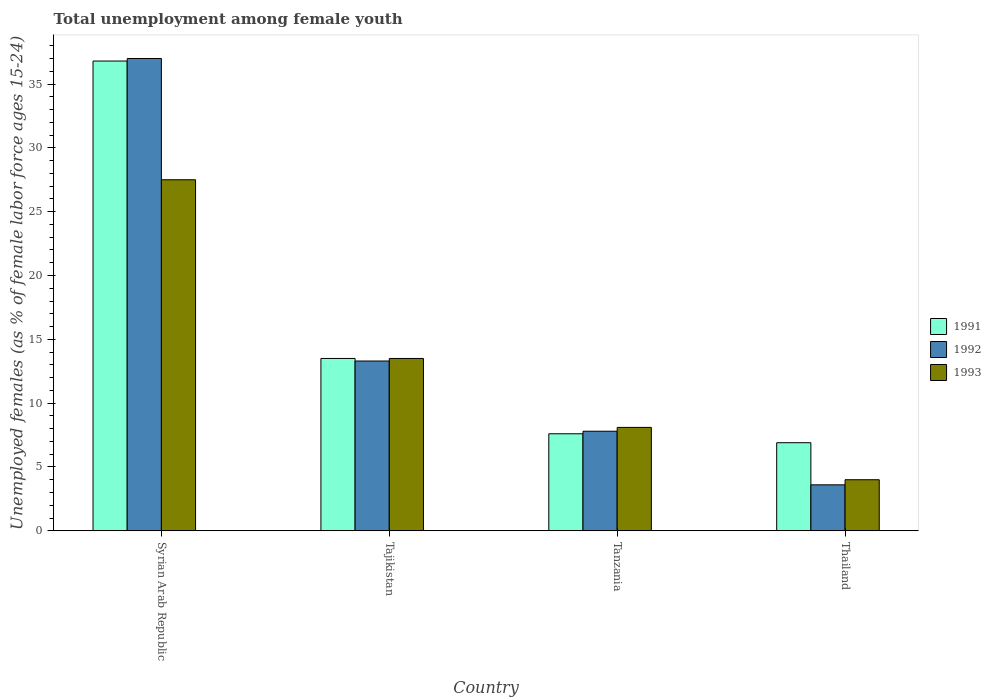How many different coloured bars are there?
Your answer should be compact. 3. How many groups of bars are there?
Your answer should be compact. 4. Are the number of bars per tick equal to the number of legend labels?
Provide a short and direct response. Yes. How many bars are there on the 1st tick from the left?
Your answer should be very brief. 3. What is the label of the 1st group of bars from the left?
Your response must be concise. Syrian Arab Republic. What is the percentage of unemployed females in in 1991 in Syrian Arab Republic?
Your answer should be very brief. 36.8. Across all countries, what is the maximum percentage of unemployed females in in 1992?
Ensure brevity in your answer.  37. In which country was the percentage of unemployed females in in 1991 maximum?
Make the answer very short. Syrian Arab Republic. In which country was the percentage of unemployed females in in 1991 minimum?
Give a very brief answer. Thailand. What is the total percentage of unemployed females in in 1991 in the graph?
Offer a very short reply. 64.8. What is the difference between the percentage of unemployed females in in 1991 in Tanzania and that in Thailand?
Offer a very short reply. 0.7. What is the difference between the percentage of unemployed females in in 1993 in Syrian Arab Republic and the percentage of unemployed females in in 1991 in Tanzania?
Make the answer very short. 19.9. What is the average percentage of unemployed females in in 1991 per country?
Offer a terse response. 16.2. What is the ratio of the percentage of unemployed females in in 1992 in Syrian Arab Republic to that in Tanzania?
Ensure brevity in your answer.  4.74. Is the difference between the percentage of unemployed females in in 1992 in Syrian Arab Republic and Tanzania greater than the difference between the percentage of unemployed females in in 1993 in Syrian Arab Republic and Tanzania?
Provide a short and direct response. Yes. What is the difference between the highest and the second highest percentage of unemployed females in in 1992?
Offer a terse response. -23.7. What is the difference between the highest and the lowest percentage of unemployed females in in 1992?
Offer a very short reply. 33.4. What does the 2nd bar from the left in Syrian Arab Republic represents?
Your answer should be compact. 1992. What does the 1st bar from the right in Syrian Arab Republic represents?
Give a very brief answer. 1993. Is it the case that in every country, the sum of the percentage of unemployed females in in 1991 and percentage of unemployed females in in 1993 is greater than the percentage of unemployed females in in 1992?
Your answer should be very brief. Yes. How many countries are there in the graph?
Give a very brief answer. 4. What is the difference between two consecutive major ticks on the Y-axis?
Ensure brevity in your answer.  5. Are the values on the major ticks of Y-axis written in scientific E-notation?
Provide a short and direct response. No. Does the graph contain any zero values?
Provide a short and direct response. No. Where does the legend appear in the graph?
Make the answer very short. Center right. How many legend labels are there?
Offer a terse response. 3. What is the title of the graph?
Offer a very short reply. Total unemployment among female youth. What is the label or title of the Y-axis?
Ensure brevity in your answer.  Unemployed females (as % of female labor force ages 15-24). What is the Unemployed females (as % of female labor force ages 15-24) in 1991 in Syrian Arab Republic?
Provide a succinct answer. 36.8. What is the Unemployed females (as % of female labor force ages 15-24) of 1991 in Tajikistan?
Provide a succinct answer. 13.5. What is the Unemployed females (as % of female labor force ages 15-24) in 1992 in Tajikistan?
Your answer should be very brief. 13.3. What is the Unemployed females (as % of female labor force ages 15-24) of 1993 in Tajikistan?
Keep it short and to the point. 13.5. What is the Unemployed females (as % of female labor force ages 15-24) in 1991 in Tanzania?
Provide a succinct answer. 7.6. What is the Unemployed females (as % of female labor force ages 15-24) in 1992 in Tanzania?
Your answer should be very brief. 7.8. What is the Unemployed females (as % of female labor force ages 15-24) in 1993 in Tanzania?
Offer a terse response. 8.1. What is the Unemployed females (as % of female labor force ages 15-24) in 1991 in Thailand?
Your answer should be very brief. 6.9. What is the Unemployed females (as % of female labor force ages 15-24) of 1992 in Thailand?
Offer a very short reply. 3.6. Across all countries, what is the maximum Unemployed females (as % of female labor force ages 15-24) in 1991?
Your answer should be very brief. 36.8. Across all countries, what is the maximum Unemployed females (as % of female labor force ages 15-24) in 1992?
Offer a terse response. 37. Across all countries, what is the minimum Unemployed females (as % of female labor force ages 15-24) in 1991?
Your response must be concise. 6.9. Across all countries, what is the minimum Unemployed females (as % of female labor force ages 15-24) of 1992?
Keep it short and to the point. 3.6. What is the total Unemployed females (as % of female labor force ages 15-24) in 1991 in the graph?
Provide a short and direct response. 64.8. What is the total Unemployed females (as % of female labor force ages 15-24) of 1992 in the graph?
Offer a very short reply. 61.7. What is the total Unemployed females (as % of female labor force ages 15-24) of 1993 in the graph?
Your response must be concise. 53.1. What is the difference between the Unemployed females (as % of female labor force ages 15-24) in 1991 in Syrian Arab Republic and that in Tajikistan?
Your response must be concise. 23.3. What is the difference between the Unemployed females (as % of female labor force ages 15-24) in 1992 in Syrian Arab Republic and that in Tajikistan?
Offer a very short reply. 23.7. What is the difference between the Unemployed females (as % of female labor force ages 15-24) of 1991 in Syrian Arab Republic and that in Tanzania?
Provide a short and direct response. 29.2. What is the difference between the Unemployed females (as % of female labor force ages 15-24) in 1992 in Syrian Arab Republic and that in Tanzania?
Provide a succinct answer. 29.2. What is the difference between the Unemployed females (as % of female labor force ages 15-24) in 1991 in Syrian Arab Republic and that in Thailand?
Provide a short and direct response. 29.9. What is the difference between the Unemployed females (as % of female labor force ages 15-24) in 1992 in Syrian Arab Republic and that in Thailand?
Ensure brevity in your answer.  33.4. What is the difference between the Unemployed females (as % of female labor force ages 15-24) of 1993 in Syrian Arab Republic and that in Thailand?
Your response must be concise. 23.5. What is the difference between the Unemployed females (as % of female labor force ages 15-24) of 1991 in Tajikistan and that in Thailand?
Provide a succinct answer. 6.6. What is the difference between the Unemployed females (as % of female labor force ages 15-24) of 1993 in Tajikistan and that in Thailand?
Keep it short and to the point. 9.5. What is the difference between the Unemployed females (as % of female labor force ages 15-24) in 1991 in Syrian Arab Republic and the Unemployed females (as % of female labor force ages 15-24) in 1993 in Tajikistan?
Give a very brief answer. 23.3. What is the difference between the Unemployed females (as % of female labor force ages 15-24) of 1991 in Syrian Arab Republic and the Unemployed females (as % of female labor force ages 15-24) of 1993 in Tanzania?
Make the answer very short. 28.7. What is the difference between the Unemployed females (as % of female labor force ages 15-24) in 1992 in Syrian Arab Republic and the Unemployed females (as % of female labor force ages 15-24) in 1993 in Tanzania?
Keep it short and to the point. 28.9. What is the difference between the Unemployed females (as % of female labor force ages 15-24) of 1991 in Syrian Arab Republic and the Unemployed females (as % of female labor force ages 15-24) of 1992 in Thailand?
Your answer should be compact. 33.2. What is the difference between the Unemployed females (as % of female labor force ages 15-24) of 1991 in Syrian Arab Republic and the Unemployed females (as % of female labor force ages 15-24) of 1993 in Thailand?
Provide a short and direct response. 32.8. What is the difference between the Unemployed females (as % of female labor force ages 15-24) of 1992 in Syrian Arab Republic and the Unemployed females (as % of female labor force ages 15-24) of 1993 in Thailand?
Offer a very short reply. 33. What is the difference between the Unemployed females (as % of female labor force ages 15-24) of 1991 in Tajikistan and the Unemployed females (as % of female labor force ages 15-24) of 1992 in Thailand?
Your answer should be compact. 9.9. What is the difference between the Unemployed females (as % of female labor force ages 15-24) of 1991 in Tajikistan and the Unemployed females (as % of female labor force ages 15-24) of 1993 in Thailand?
Offer a terse response. 9.5. What is the difference between the Unemployed females (as % of female labor force ages 15-24) of 1992 in Tajikistan and the Unemployed females (as % of female labor force ages 15-24) of 1993 in Thailand?
Your answer should be compact. 9.3. What is the difference between the Unemployed females (as % of female labor force ages 15-24) of 1991 in Tanzania and the Unemployed females (as % of female labor force ages 15-24) of 1992 in Thailand?
Your answer should be very brief. 4. What is the average Unemployed females (as % of female labor force ages 15-24) in 1991 per country?
Offer a very short reply. 16.2. What is the average Unemployed females (as % of female labor force ages 15-24) of 1992 per country?
Give a very brief answer. 15.43. What is the average Unemployed females (as % of female labor force ages 15-24) of 1993 per country?
Offer a terse response. 13.28. What is the difference between the Unemployed females (as % of female labor force ages 15-24) in 1991 and Unemployed females (as % of female labor force ages 15-24) in 1993 in Syrian Arab Republic?
Offer a terse response. 9.3. What is the difference between the Unemployed females (as % of female labor force ages 15-24) in 1992 and Unemployed females (as % of female labor force ages 15-24) in 1993 in Syrian Arab Republic?
Give a very brief answer. 9.5. What is the difference between the Unemployed females (as % of female labor force ages 15-24) in 1991 and Unemployed females (as % of female labor force ages 15-24) in 1992 in Tajikistan?
Your response must be concise. 0.2. What is the difference between the Unemployed females (as % of female labor force ages 15-24) of 1991 and Unemployed females (as % of female labor force ages 15-24) of 1993 in Tajikistan?
Provide a short and direct response. 0. What is the difference between the Unemployed females (as % of female labor force ages 15-24) in 1991 and Unemployed females (as % of female labor force ages 15-24) in 1992 in Tanzania?
Ensure brevity in your answer.  -0.2. What is the difference between the Unemployed females (as % of female labor force ages 15-24) in 1992 and Unemployed females (as % of female labor force ages 15-24) in 1993 in Tanzania?
Offer a very short reply. -0.3. What is the ratio of the Unemployed females (as % of female labor force ages 15-24) of 1991 in Syrian Arab Republic to that in Tajikistan?
Your answer should be very brief. 2.73. What is the ratio of the Unemployed females (as % of female labor force ages 15-24) of 1992 in Syrian Arab Republic to that in Tajikistan?
Provide a short and direct response. 2.78. What is the ratio of the Unemployed females (as % of female labor force ages 15-24) of 1993 in Syrian Arab Republic to that in Tajikistan?
Your answer should be compact. 2.04. What is the ratio of the Unemployed females (as % of female labor force ages 15-24) in 1991 in Syrian Arab Republic to that in Tanzania?
Offer a terse response. 4.84. What is the ratio of the Unemployed females (as % of female labor force ages 15-24) of 1992 in Syrian Arab Republic to that in Tanzania?
Your answer should be compact. 4.74. What is the ratio of the Unemployed females (as % of female labor force ages 15-24) of 1993 in Syrian Arab Republic to that in Tanzania?
Your response must be concise. 3.4. What is the ratio of the Unemployed females (as % of female labor force ages 15-24) of 1991 in Syrian Arab Republic to that in Thailand?
Offer a very short reply. 5.33. What is the ratio of the Unemployed females (as % of female labor force ages 15-24) in 1992 in Syrian Arab Republic to that in Thailand?
Your answer should be very brief. 10.28. What is the ratio of the Unemployed females (as % of female labor force ages 15-24) of 1993 in Syrian Arab Republic to that in Thailand?
Your answer should be very brief. 6.88. What is the ratio of the Unemployed females (as % of female labor force ages 15-24) in 1991 in Tajikistan to that in Tanzania?
Provide a short and direct response. 1.78. What is the ratio of the Unemployed females (as % of female labor force ages 15-24) of 1992 in Tajikistan to that in Tanzania?
Keep it short and to the point. 1.71. What is the ratio of the Unemployed females (as % of female labor force ages 15-24) of 1993 in Tajikistan to that in Tanzania?
Ensure brevity in your answer.  1.67. What is the ratio of the Unemployed females (as % of female labor force ages 15-24) in 1991 in Tajikistan to that in Thailand?
Make the answer very short. 1.96. What is the ratio of the Unemployed females (as % of female labor force ages 15-24) of 1992 in Tajikistan to that in Thailand?
Ensure brevity in your answer.  3.69. What is the ratio of the Unemployed females (as % of female labor force ages 15-24) of 1993 in Tajikistan to that in Thailand?
Provide a succinct answer. 3.38. What is the ratio of the Unemployed females (as % of female labor force ages 15-24) in 1991 in Tanzania to that in Thailand?
Keep it short and to the point. 1.1. What is the ratio of the Unemployed females (as % of female labor force ages 15-24) in 1992 in Tanzania to that in Thailand?
Offer a very short reply. 2.17. What is the ratio of the Unemployed females (as % of female labor force ages 15-24) of 1993 in Tanzania to that in Thailand?
Offer a terse response. 2.02. What is the difference between the highest and the second highest Unemployed females (as % of female labor force ages 15-24) in 1991?
Provide a succinct answer. 23.3. What is the difference between the highest and the second highest Unemployed females (as % of female labor force ages 15-24) of 1992?
Your response must be concise. 23.7. What is the difference between the highest and the second highest Unemployed females (as % of female labor force ages 15-24) of 1993?
Give a very brief answer. 14. What is the difference between the highest and the lowest Unemployed females (as % of female labor force ages 15-24) in 1991?
Provide a succinct answer. 29.9. What is the difference between the highest and the lowest Unemployed females (as % of female labor force ages 15-24) of 1992?
Offer a very short reply. 33.4. 